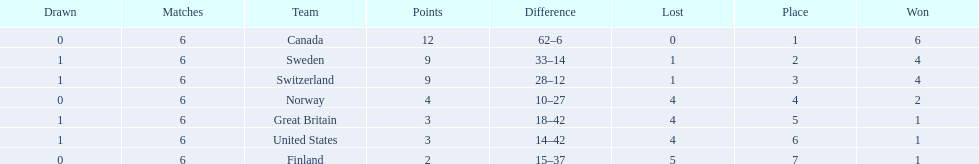What are the names of the countries? Canada, Sweden, Switzerland, Norway, Great Britain, United States, Finland. How many wins did switzerland have? 4. How many wins did great britain have? 1. Which country had more wins, great britain or switzerland? Switzerland. 